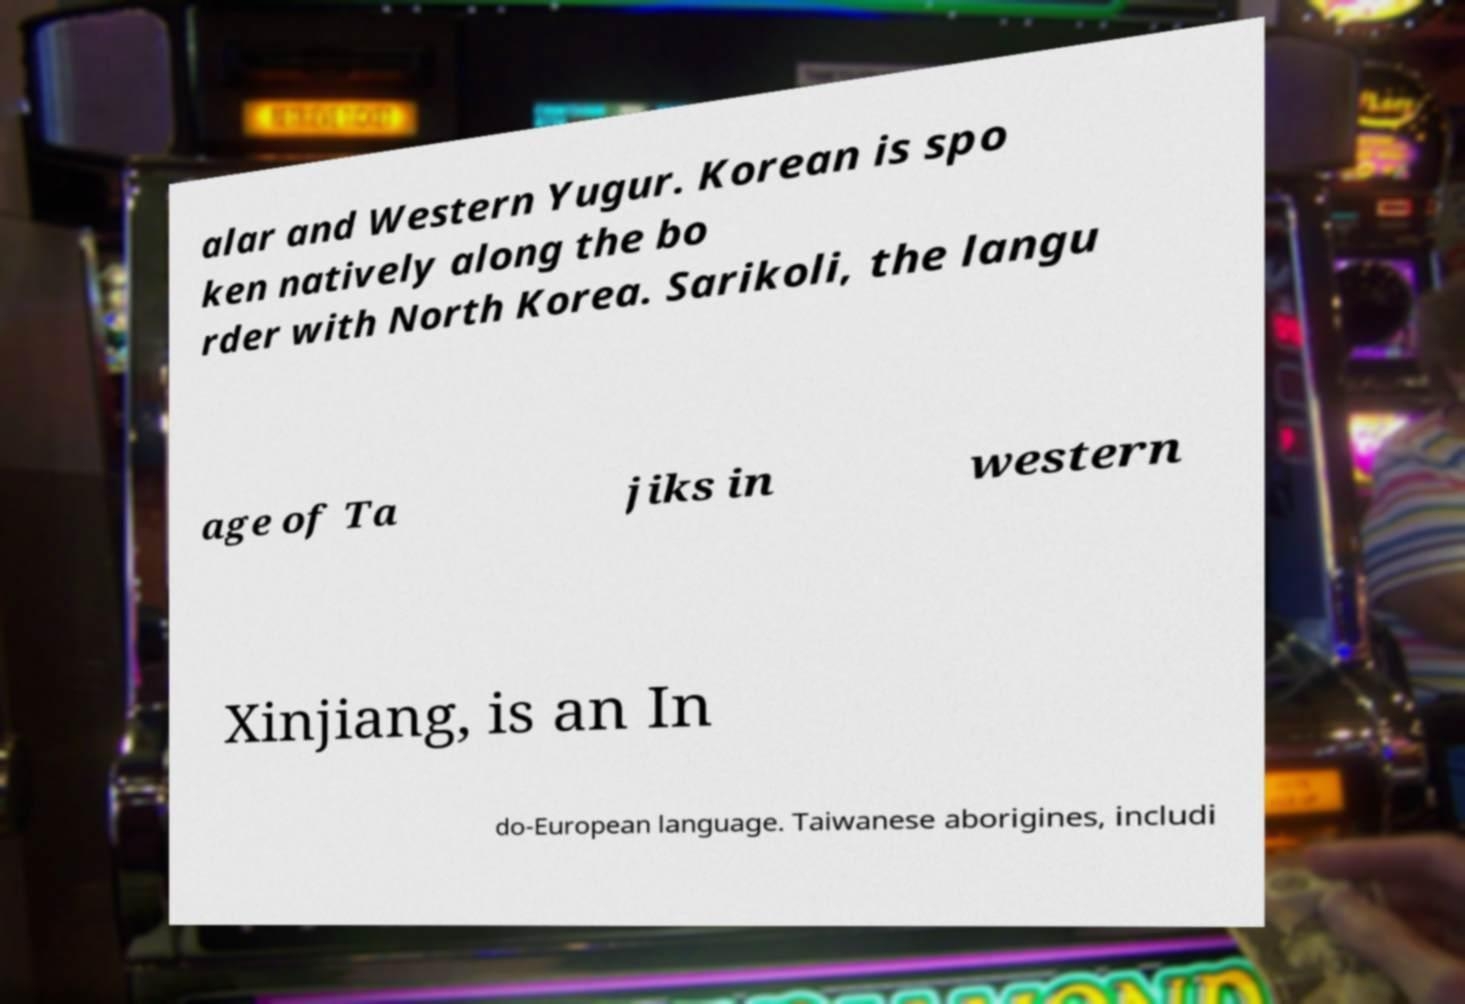Can you read and provide the text displayed in the image?This photo seems to have some interesting text. Can you extract and type it out for me? alar and Western Yugur. Korean is spo ken natively along the bo rder with North Korea. Sarikoli, the langu age of Ta jiks in western Xinjiang, is an In do-European language. Taiwanese aborigines, includi 